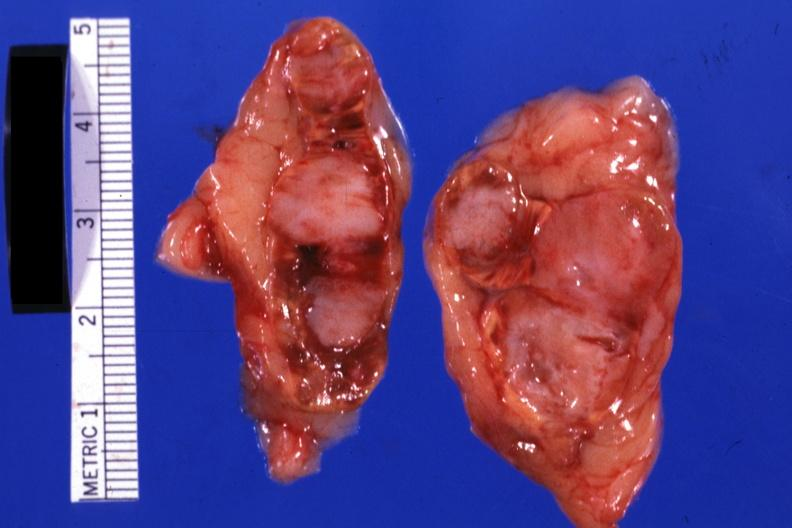does this image show extensive lesions scar carcinoma in lung?
Answer the question using a single word or phrase. Yes 